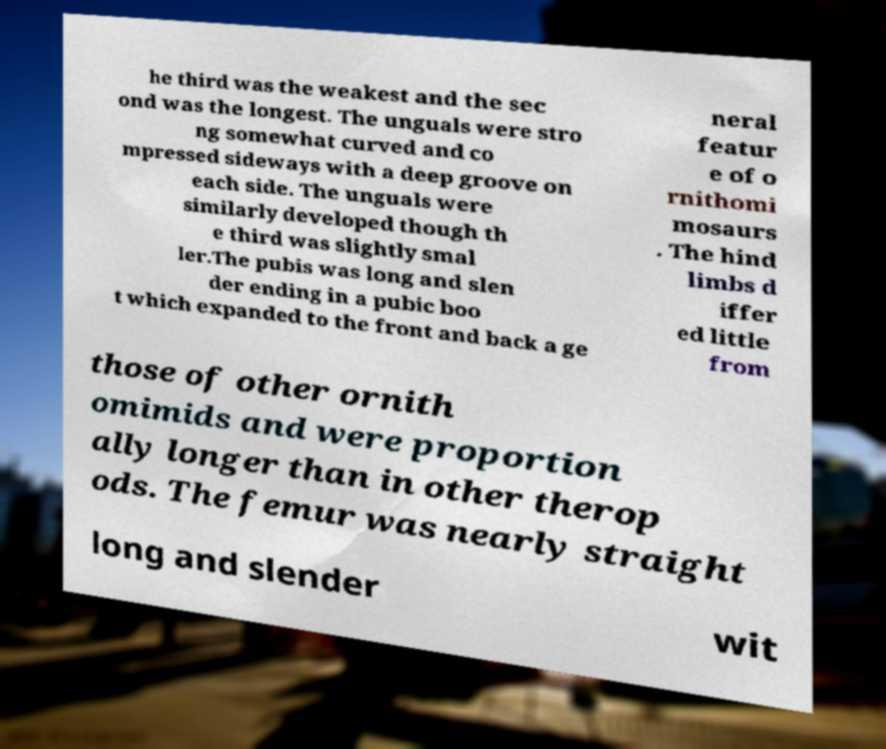Please identify and transcribe the text found in this image. he third was the weakest and the sec ond was the longest. The unguals were stro ng somewhat curved and co mpressed sideways with a deep groove on each side. The unguals were similarly developed though th e third was slightly smal ler.The pubis was long and slen der ending in a pubic boo t which expanded to the front and back a ge neral featur e of o rnithomi mosaurs . The hind limbs d iffer ed little from those of other ornith omimids and were proportion ally longer than in other therop ods. The femur was nearly straight long and slender wit 